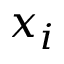<formula> <loc_0><loc_0><loc_500><loc_500>x _ { i }</formula> 